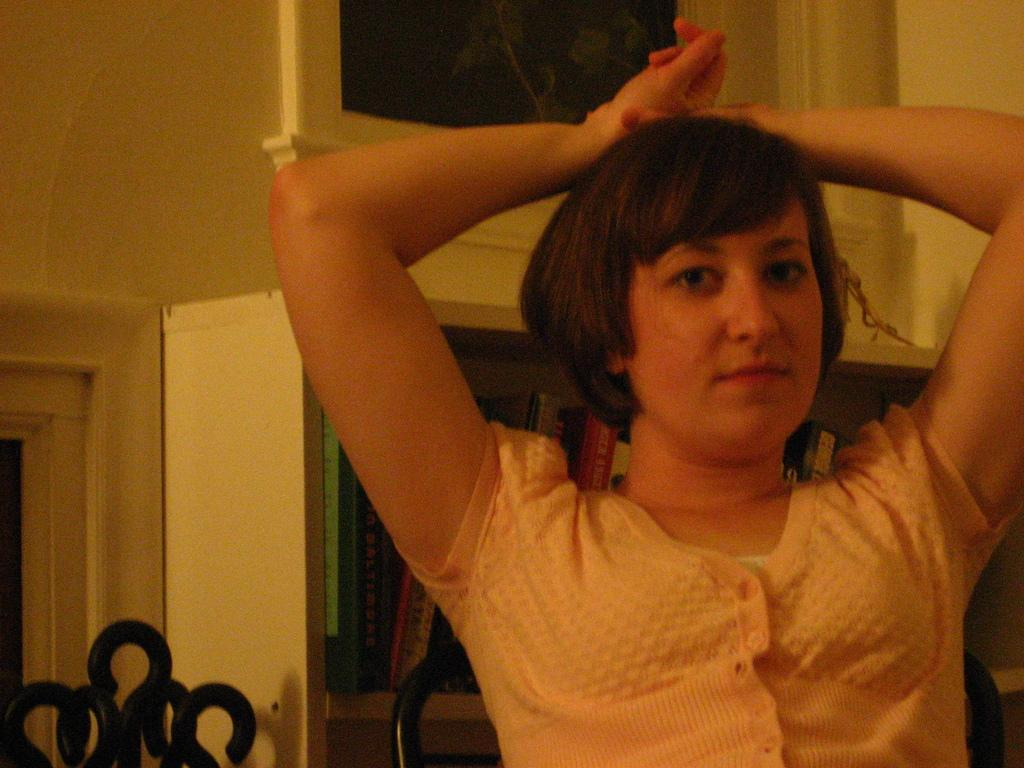Who is the main subject in the image? There is a woman in the image. What is the woman doing with her hands? The woman is holding her hands on her head. What can be seen in the background of the image? There are books on shelves in the background of the image. What language is the woman speaking in the image? The image does not provide any information about the language being spoken, as there is no audio or text present. 